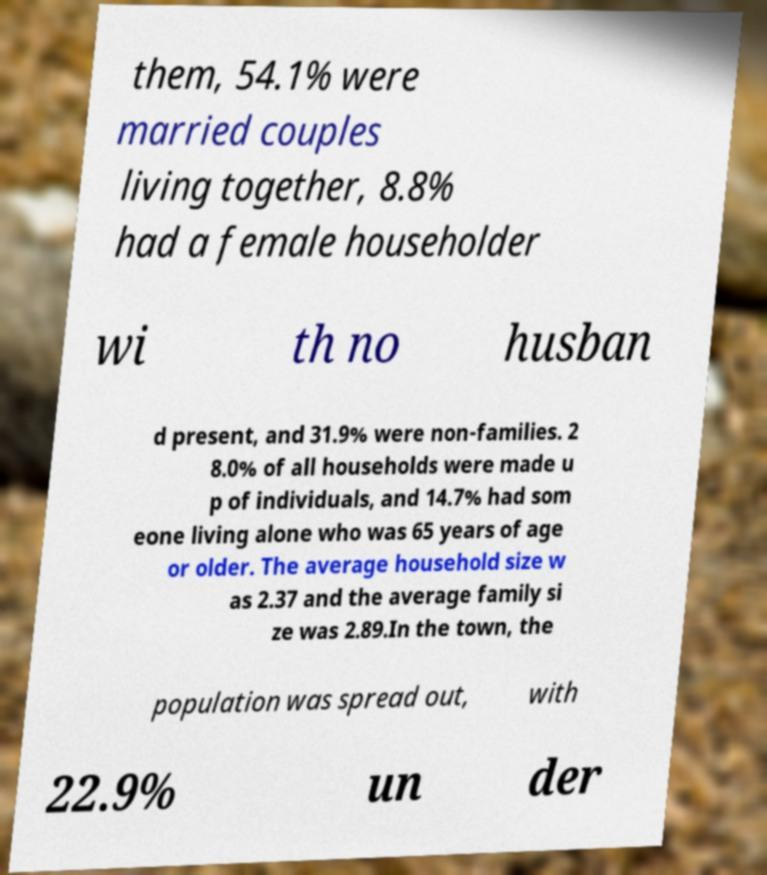Could you assist in decoding the text presented in this image and type it out clearly? them, 54.1% were married couples living together, 8.8% had a female householder wi th no husban d present, and 31.9% were non-families. 2 8.0% of all households were made u p of individuals, and 14.7% had som eone living alone who was 65 years of age or older. The average household size w as 2.37 and the average family si ze was 2.89.In the town, the population was spread out, with 22.9% un der 